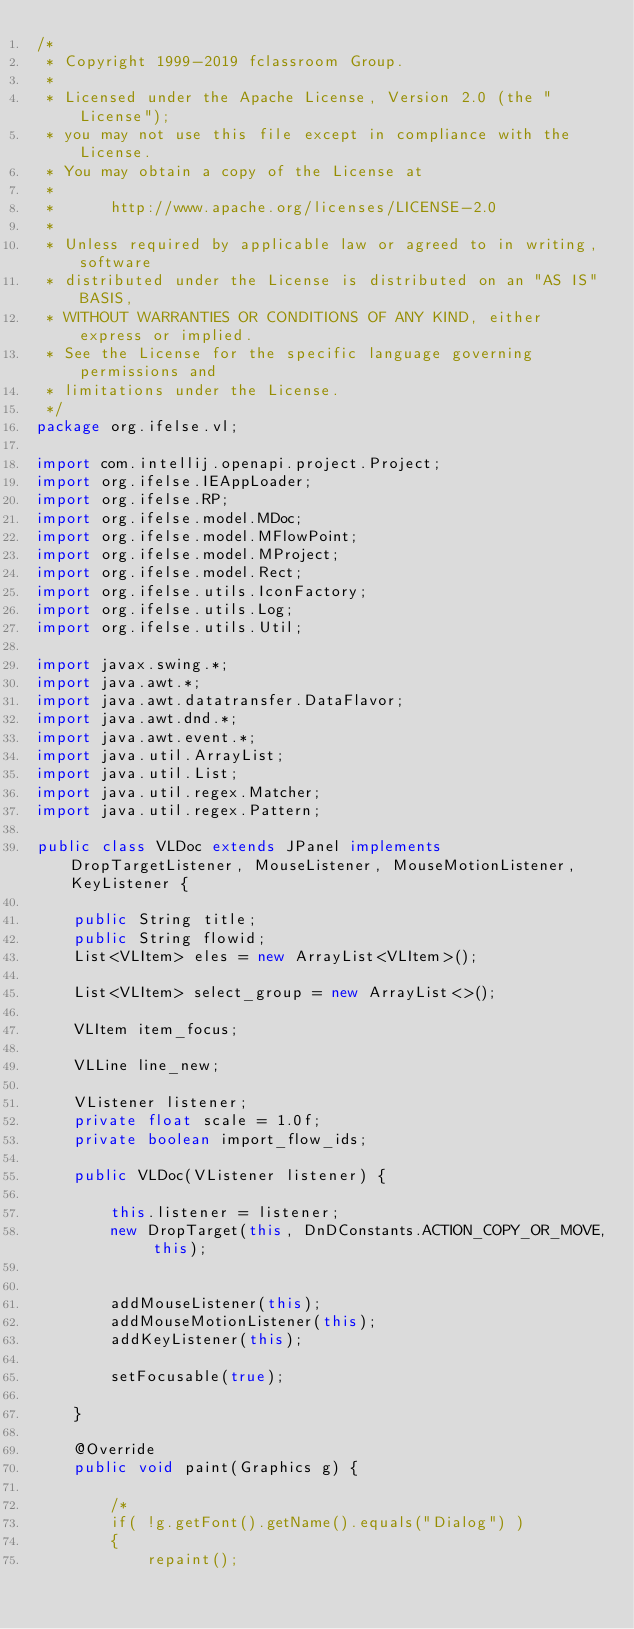Convert code to text. <code><loc_0><loc_0><loc_500><loc_500><_Java_>/*
 * Copyright 1999-2019 fclassroom Group.
 *
 * Licensed under the Apache License, Version 2.0 (the "License");
 * you may not use this file except in compliance with the License.
 * You may obtain a copy of the License at
 *
 *      http://www.apache.org/licenses/LICENSE-2.0
 *
 * Unless required by applicable law or agreed to in writing, software
 * distributed under the License is distributed on an "AS IS" BASIS,
 * WITHOUT WARRANTIES OR CONDITIONS OF ANY KIND, either express or implied.
 * See the License for the specific language governing permissions and
 * limitations under the License.
 */
package org.ifelse.vl;

import com.intellij.openapi.project.Project;
import org.ifelse.IEAppLoader;
import org.ifelse.RP;
import org.ifelse.model.MDoc;
import org.ifelse.model.MFlowPoint;
import org.ifelse.model.MProject;
import org.ifelse.model.Rect;
import org.ifelse.utils.IconFactory;
import org.ifelse.utils.Log;
import org.ifelse.utils.Util;

import javax.swing.*;
import java.awt.*;
import java.awt.datatransfer.DataFlavor;
import java.awt.dnd.*;
import java.awt.event.*;
import java.util.ArrayList;
import java.util.List;
import java.util.regex.Matcher;
import java.util.regex.Pattern;

public class VLDoc extends JPanel implements DropTargetListener, MouseListener, MouseMotionListener, KeyListener {

    public String title;
    public String flowid;
    List<VLItem> eles = new ArrayList<VLItem>();

    List<VLItem> select_group = new ArrayList<>();

    VLItem item_focus;

    VLLine line_new;

    VListener listener;
    private float scale = 1.0f;
    private boolean import_flow_ids;

    public VLDoc(VListener listener) {

        this.listener = listener;
        new DropTarget(this, DnDConstants.ACTION_COPY_OR_MOVE, this);


        addMouseListener(this);
        addMouseMotionListener(this);
        addKeyListener(this);

        setFocusable(true);

    }

    @Override
    public void paint(Graphics g) {

        /*
        if( !g.getFont().getName().equals("Dialog") )
        {
            repaint();</code> 